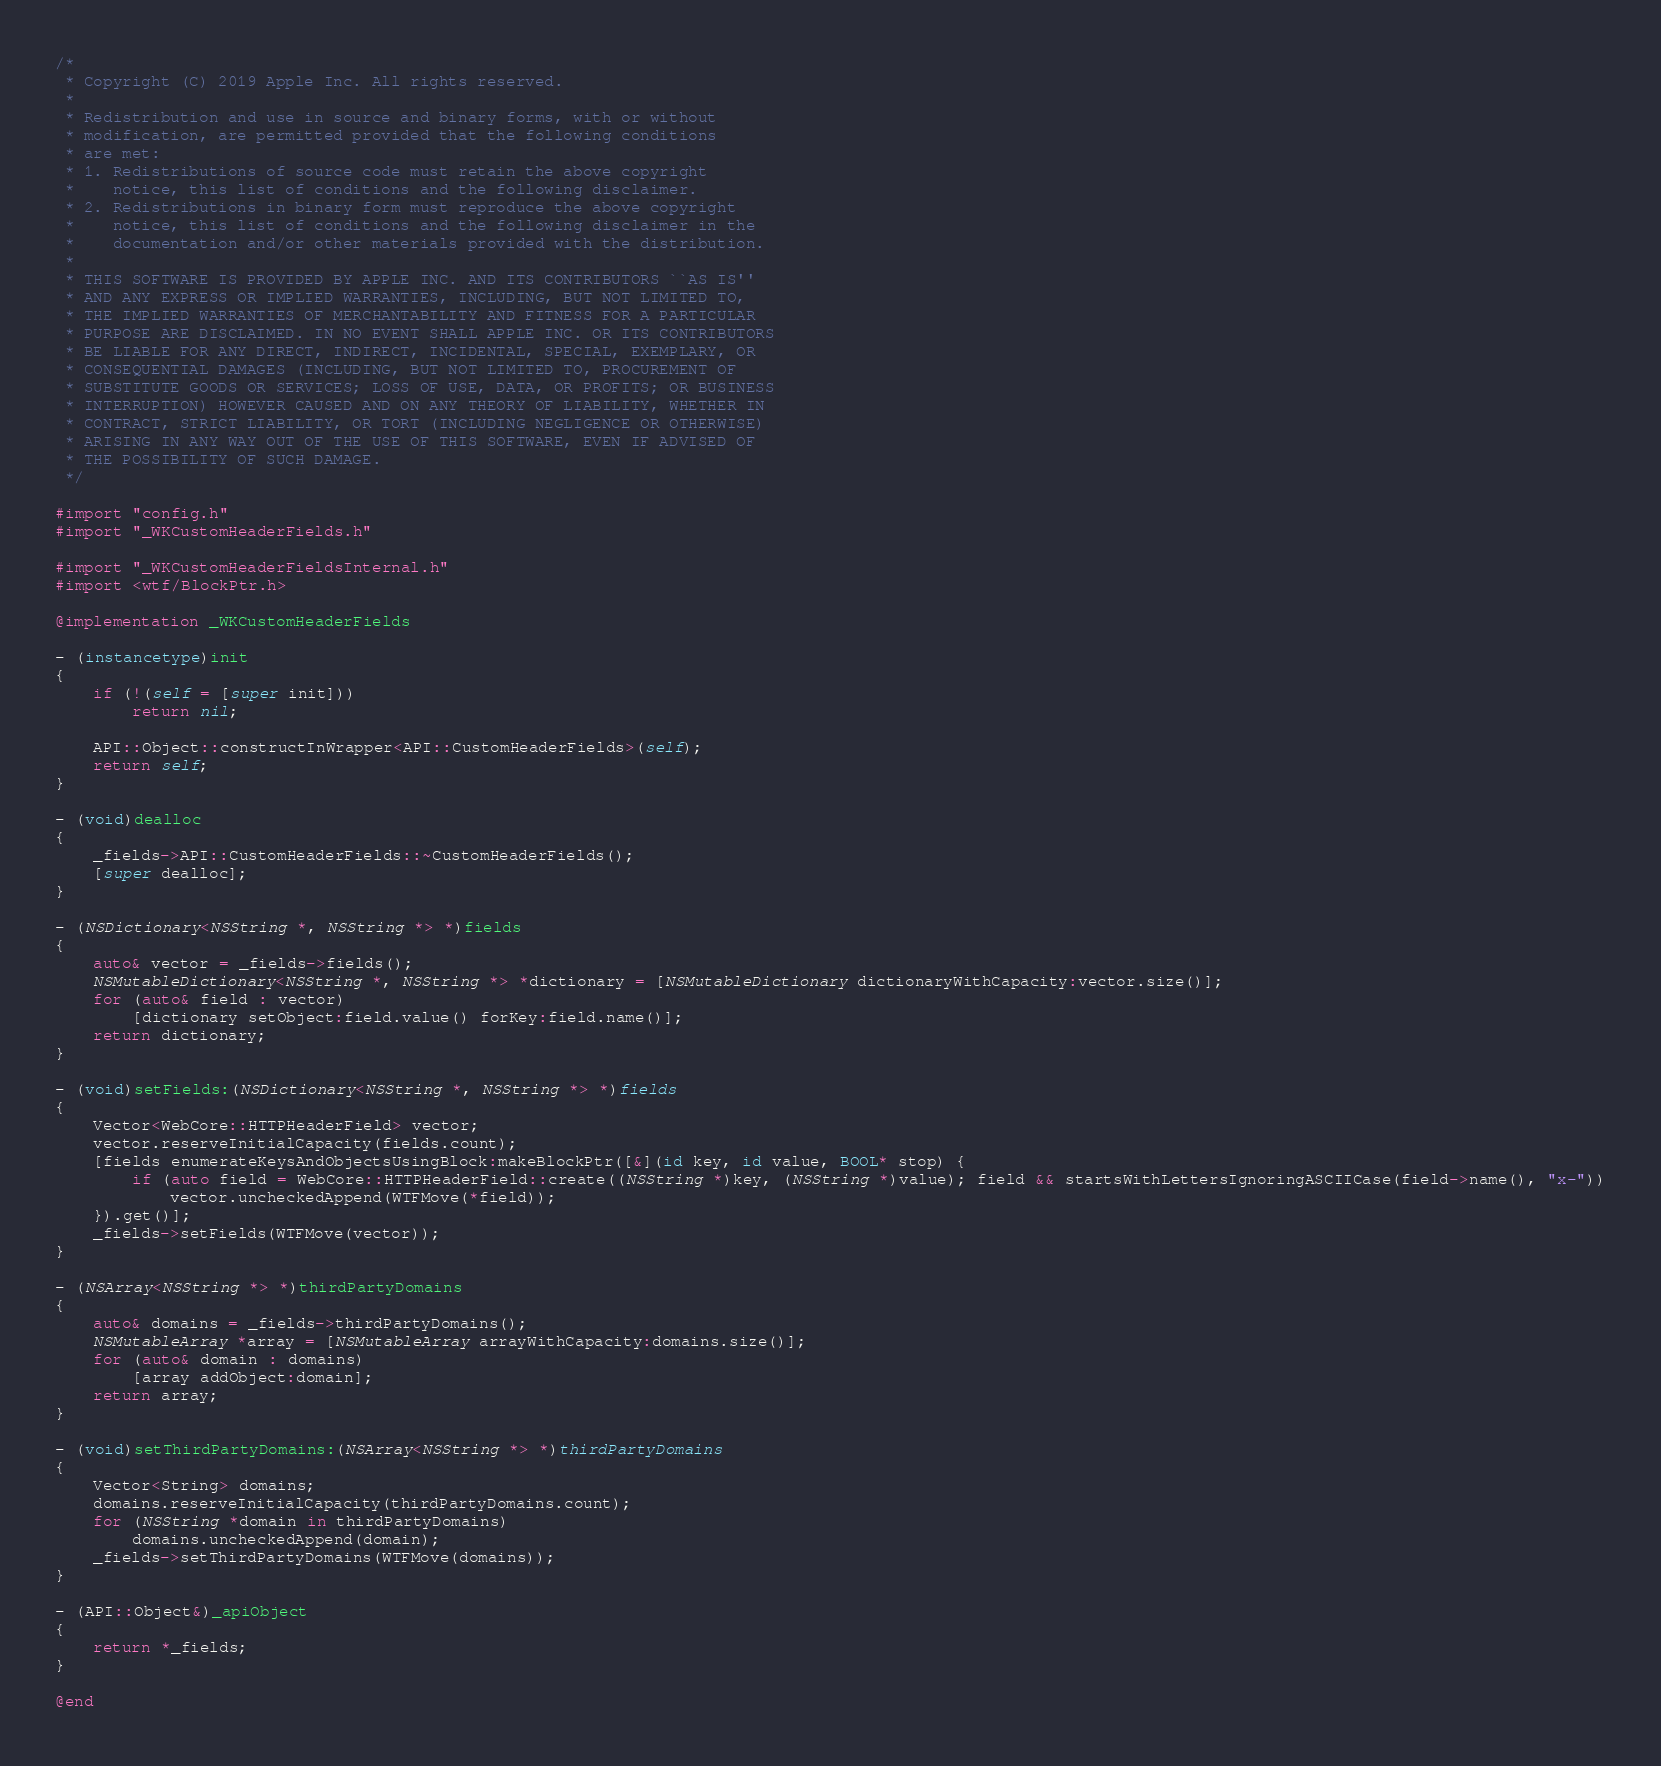<code> <loc_0><loc_0><loc_500><loc_500><_ObjectiveC_>/*
 * Copyright (C) 2019 Apple Inc. All rights reserved.
 *
 * Redistribution and use in source and binary forms, with or without
 * modification, are permitted provided that the following conditions
 * are met:
 * 1. Redistributions of source code must retain the above copyright
 *    notice, this list of conditions and the following disclaimer.
 * 2. Redistributions in binary form must reproduce the above copyright
 *    notice, this list of conditions and the following disclaimer in the
 *    documentation and/or other materials provided with the distribution.
 *
 * THIS SOFTWARE IS PROVIDED BY APPLE INC. AND ITS CONTRIBUTORS ``AS IS''
 * AND ANY EXPRESS OR IMPLIED WARRANTIES, INCLUDING, BUT NOT LIMITED TO,
 * THE IMPLIED WARRANTIES OF MERCHANTABILITY AND FITNESS FOR A PARTICULAR
 * PURPOSE ARE DISCLAIMED. IN NO EVENT SHALL APPLE INC. OR ITS CONTRIBUTORS
 * BE LIABLE FOR ANY DIRECT, INDIRECT, INCIDENTAL, SPECIAL, EXEMPLARY, OR
 * CONSEQUENTIAL DAMAGES (INCLUDING, BUT NOT LIMITED TO, PROCUREMENT OF
 * SUBSTITUTE GOODS OR SERVICES; LOSS OF USE, DATA, OR PROFITS; OR BUSINESS
 * INTERRUPTION) HOWEVER CAUSED AND ON ANY THEORY OF LIABILITY, WHETHER IN
 * CONTRACT, STRICT LIABILITY, OR TORT (INCLUDING NEGLIGENCE OR OTHERWISE)
 * ARISING IN ANY WAY OUT OF THE USE OF THIS SOFTWARE, EVEN IF ADVISED OF
 * THE POSSIBILITY OF SUCH DAMAGE.
 */

#import "config.h"
#import "_WKCustomHeaderFields.h"

#import "_WKCustomHeaderFieldsInternal.h"
#import <wtf/BlockPtr.h>

@implementation _WKCustomHeaderFields

- (instancetype)init
{
    if (!(self = [super init]))
        return nil;
    
    API::Object::constructInWrapper<API::CustomHeaderFields>(self);
    return self;
}

- (void)dealloc
{
    _fields->API::CustomHeaderFields::~CustomHeaderFields();
    [super dealloc];
}

- (NSDictionary<NSString *, NSString *> *)fields
{
    auto& vector = _fields->fields();
    NSMutableDictionary<NSString *, NSString *> *dictionary = [NSMutableDictionary dictionaryWithCapacity:vector.size()];
    for (auto& field : vector)
        [dictionary setObject:field.value() forKey:field.name()];
    return dictionary;
}

- (void)setFields:(NSDictionary<NSString *, NSString *> *)fields
{
    Vector<WebCore::HTTPHeaderField> vector;
    vector.reserveInitialCapacity(fields.count);
    [fields enumerateKeysAndObjectsUsingBlock:makeBlockPtr([&](id key, id value, BOOL* stop) {
        if (auto field = WebCore::HTTPHeaderField::create((NSString *)key, (NSString *)value); field && startsWithLettersIgnoringASCIICase(field->name(), "x-"))
            vector.uncheckedAppend(WTFMove(*field));
    }).get()];
    _fields->setFields(WTFMove(vector));
}

- (NSArray<NSString *> *)thirdPartyDomains
{
    auto& domains = _fields->thirdPartyDomains();
    NSMutableArray *array = [NSMutableArray arrayWithCapacity:domains.size()];
    for (auto& domain : domains)
        [array addObject:domain];
    return array;
}

- (void)setThirdPartyDomains:(NSArray<NSString *> *)thirdPartyDomains
{
    Vector<String> domains;
    domains.reserveInitialCapacity(thirdPartyDomains.count);
    for (NSString *domain in thirdPartyDomains)
        domains.uncheckedAppend(domain);
    _fields->setThirdPartyDomains(WTFMove(domains));
}

- (API::Object&)_apiObject
{
    return *_fields;
}

@end
</code> 